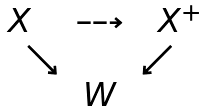<formula> <loc_0><loc_0><loc_500><loc_500>\begin{matrix} X & \dashrightarrow & \ X ^ { + } \\ { \quad \ \searrow } & \ & { \swarrow } \quad \\ \ & W & \end{matrix}</formula> 